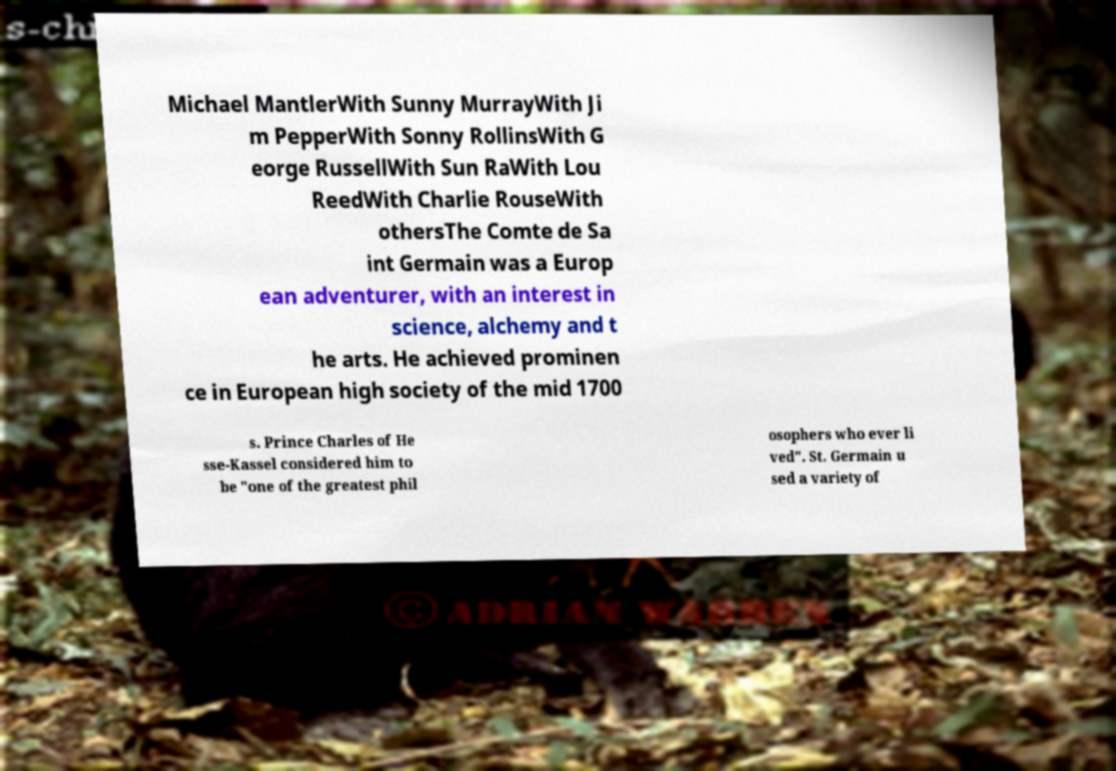Please read and relay the text visible in this image. What does it say? Michael MantlerWith Sunny MurrayWith Ji m PepperWith Sonny RollinsWith G eorge RussellWith Sun RaWith Lou ReedWith Charlie RouseWith othersThe Comte de Sa int Germain was a Europ ean adventurer, with an interest in science, alchemy and t he arts. He achieved prominen ce in European high society of the mid 1700 s. Prince Charles of He sse-Kassel considered him to be "one of the greatest phil osophers who ever li ved". St. Germain u sed a variety of 